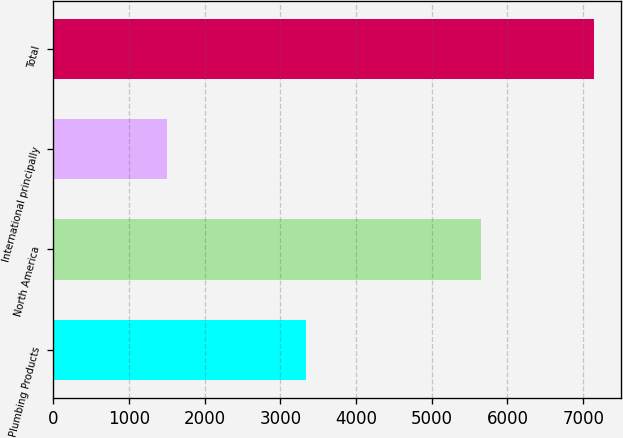<chart> <loc_0><loc_0><loc_500><loc_500><bar_chart><fcel>Plumbing Products<fcel>North America<fcel>International principally<fcel>Total<nl><fcel>3341<fcel>5645<fcel>1497<fcel>7142<nl></chart> 